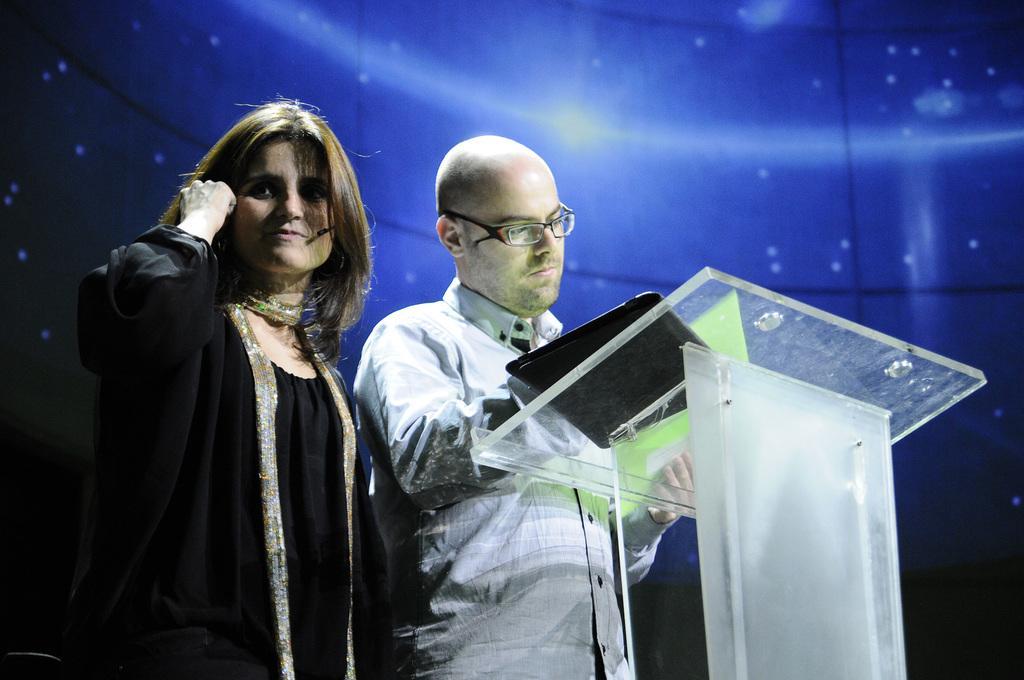How would you summarize this image in a sentence or two? In the picture we can see a woman and a man standing near to each other near the glass desk and man is holding a file which is green in color and behind them, we can see the glass wall on it we can see the blue color light focus. 